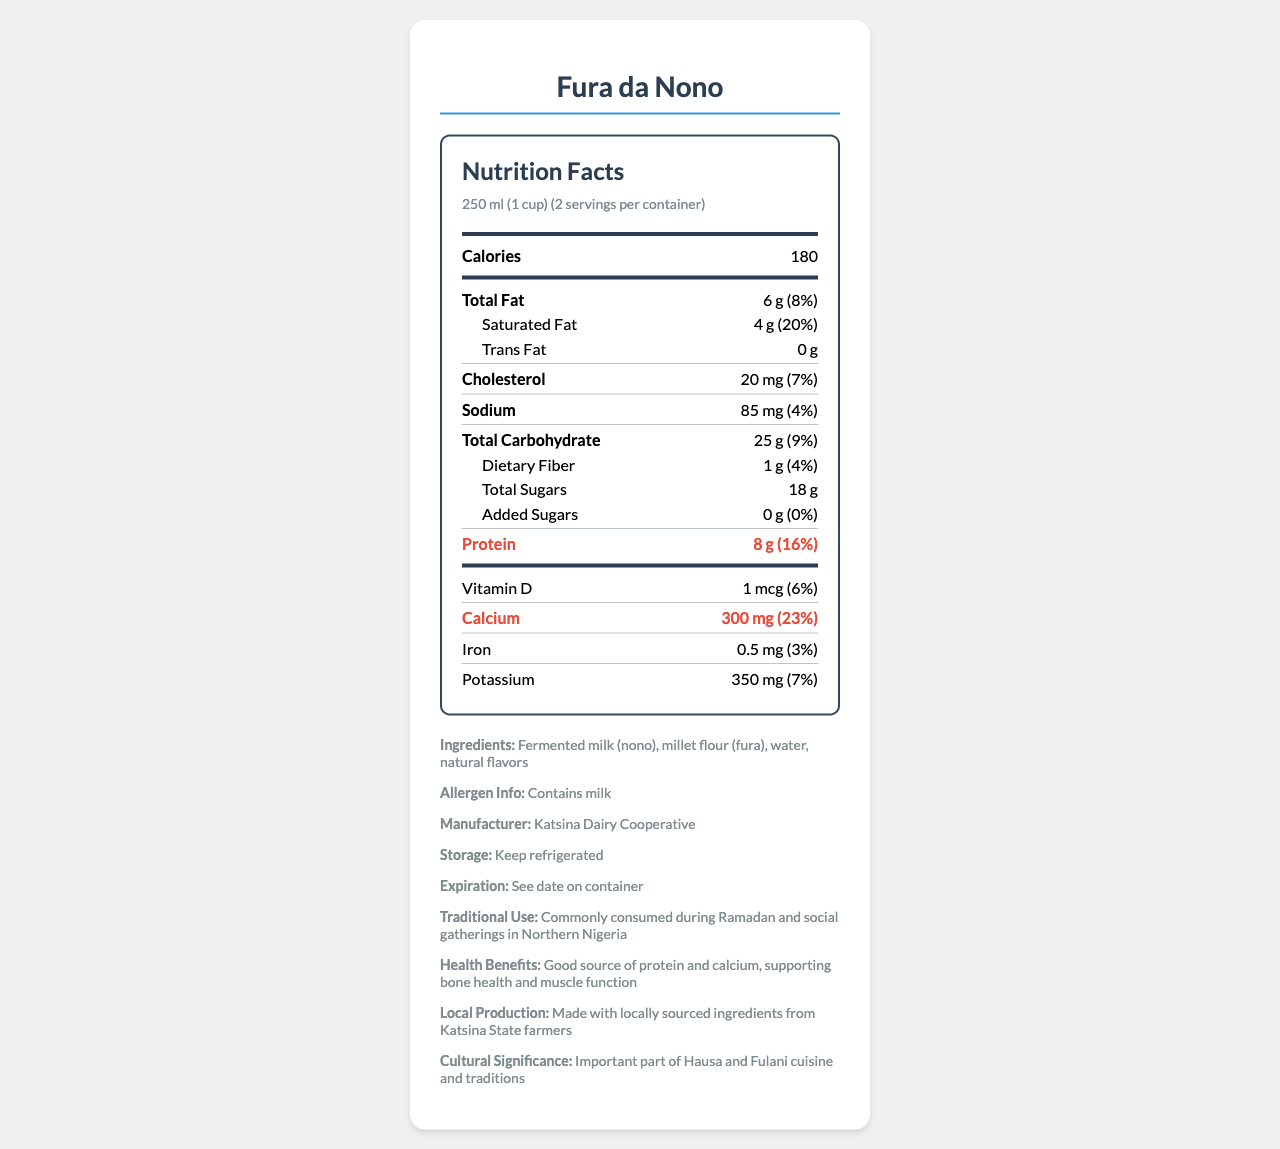what is the serving size for Fura da Nono? The serving size is listed at the top of the nutrition label as 250 ml (1 cup).
Answer: 250 ml (1 cup) how many calories are in one serving of Fura da Nono? The document states that one serving size (250 ml) contains 180 calories.
Answer: 180 what is the daily value percentage of calcium in a serving of Fura da Nono? The daily value percentage for calcium is given as 23%.
Answer: 23% what is the amount of protein in a serving of Fura da Nono? The document specifies that there are 8 grams of protein in one serving.
Answer: 8 g how much total fat is in one serving of Fura da Nono? According to the nutrition label, there are 6 grams of total fat per serving.
Answer: 6 g how many servings are in the container? The number of servings per container is clearly stated as 2.
Answer: 2 which company manufactures Fura da Nono? The manufacturer is listed at the bottom of the document as Katsina Dairy Cooperative.
Answer: Katsina Dairy Cooperative what are the ingredients of Fura da Nono? A. Nono and rice flour B. Fermented milk and millet flour C. Millet flour and coconut milk D. Water and soy flour The ingredients listed are fermented milk (nono), millet flour (fura), water, and natural flavors.
Answer: B what is the daily value percentage for protein in a serving of Fura da Nono? A. 8% B. 12% C. 16% D. 20% The document states that the daily value percentage for protein is 16%.
Answer: C how much dietary fiber is in one serving of Fura da Nono? A. 0 g B. 1 g C. 2 g D. 4 g The document indicates that there is 1 gram of dietary fiber in one serving.
Answer: B is Fura da Nono a good source of calcium? The beverage provides 23% of the daily value for calcium, which is relatively high.
Answer: Yes can the expiration date be found on the container of Fura da Nono? The additional information section advises to see the date on the container for expiration.
Answer: Yes is there added sugar in Fura da Nono? The document specifies that there are 0 grams of added sugars.
Answer: No does Fura da Nono contain milk? The allergen information section clearly states that it contains milk.
Answer: Yes what is the traditional use of Fura da Nono? The document mentions that it is traditionally consumed during Ramadan and social gatherings.
Answer: Commonly consumed during Ramadan and social gatherings in Northern Nigeria describe the nutritional benefits of Fura da Nono. The document highlights the high protein and calcium content, promoting bone health and muscle function.
Answer: Fura da Nono is a good source of protein and calcium, which support bone health and muscle function. It provides 8 grams of protein and 300 milligrams of calcium per serving. how much trans fat is in one serving of Fura da Nono? The document specifies that there are 0 grams of trans fat per serving.
Answer: 0 g are there any artificial flavors in Fura da Nono? The document only mentions "natural flavors" but does not specify the absence or presence of artificial flavors.
Answer: Not enough information what is the daily value percentage for sodium in Fura da Nono? The document lists the daily value of sodium as 4%.
Answer: 4% summarize the main nutritional components of Fura da Nono. The Fura da Nono nutrition label provides detailed information about its serving size, calorie content, fat, protein, calcium, and other nutrients, emphasizing its health benefits and traditional use.
Answer: Fura da Nono is a nutritious drink with a serving size of 250 ml. Each serving contains 180 calories, 6 grams of total fat, 8 grams of protein, and 300 milligrams of calcium. It is a good source of protein and calcium, making it beneficial for bone health and muscle function. The drink contains no added sugars and has moderate levels of sodium and saturated fat. 